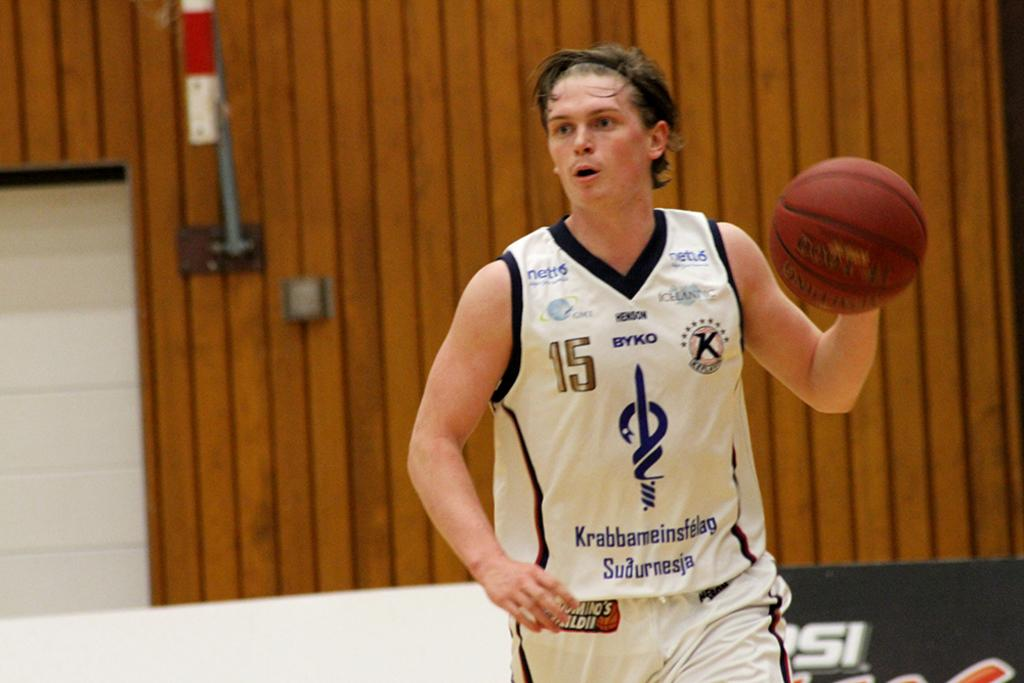Provide a one-sentence caption for the provided image. Number 15 has the basketball and is looking ahead. 